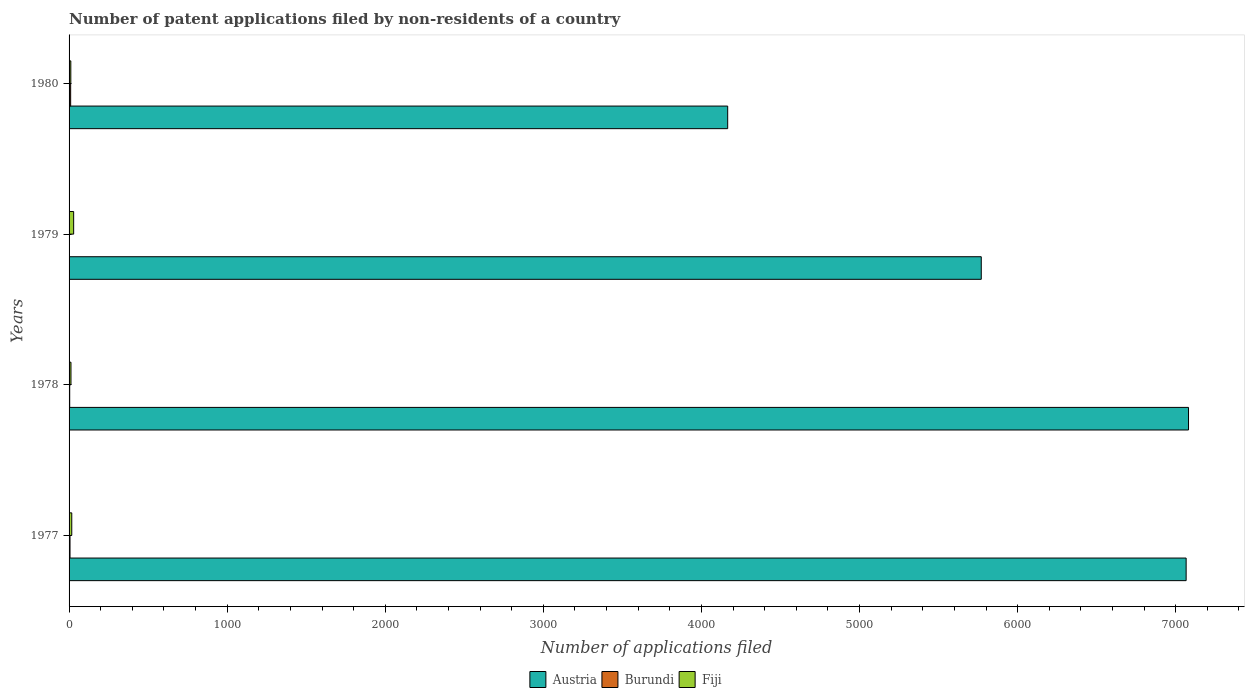Are the number of bars per tick equal to the number of legend labels?
Your answer should be compact. Yes. How many bars are there on the 2nd tick from the top?
Offer a very short reply. 3. How many bars are there on the 4th tick from the bottom?
Offer a very short reply. 3. What is the label of the 4th group of bars from the top?
Give a very brief answer. 1977. In how many cases, is the number of bars for a given year not equal to the number of legend labels?
Your answer should be very brief. 0. What is the number of applications filed in Fiji in 1977?
Make the answer very short. 17. In which year was the number of applications filed in Austria maximum?
Keep it short and to the point. 1978. In which year was the number of applications filed in Fiji minimum?
Your answer should be compact. 1980. What is the total number of applications filed in Austria in the graph?
Your answer should be very brief. 2.41e+04. What is the difference between the number of applications filed in Austria in 1979 and the number of applications filed in Fiji in 1978?
Offer a very short reply. 5758. What is the average number of applications filed in Burundi per year?
Offer a very short reply. 5.25. In the year 1977, what is the difference between the number of applications filed in Austria and number of applications filed in Fiji?
Your answer should be very brief. 7049. Is the number of applications filed in Burundi in 1978 less than that in 1979?
Offer a very short reply. No. What is the difference between the highest and the second highest number of applications filed in Fiji?
Your response must be concise. 12. What is the difference between the highest and the lowest number of applications filed in Austria?
Your answer should be compact. 2915. In how many years, is the number of applications filed in Fiji greater than the average number of applications filed in Fiji taken over all years?
Offer a very short reply. 1. What does the 1st bar from the top in 1977 represents?
Your answer should be very brief. Fiji. What does the 3rd bar from the bottom in 1979 represents?
Provide a succinct answer. Fiji. Is it the case that in every year, the sum of the number of applications filed in Fiji and number of applications filed in Burundi is greater than the number of applications filed in Austria?
Your answer should be very brief. No. How many bars are there?
Your response must be concise. 12. What is the difference between two consecutive major ticks on the X-axis?
Your answer should be compact. 1000. Does the graph contain any zero values?
Provide a short and direct response. No. How many legend labels are there?
Give a very brief answer. 3. How are the legend labels stacked?
Make the answer very short. Horizontal. What is the title of the graph?
Make the answer very short. Number of patent applications filed by non-residents of a country. What is the label or title of the X-axis?
Your answer should be very brief. Number of applications filed. What is the Number of applications filed of Austria in 1977?
Give a very brief answer. 7066. What is the Number of applications filed in Burundi in 1977?
Keep it short and to the point. 6. What is the Number of applications filed of Fiji in 1977?
Offer a very short reply. 17. What is the Number of applications filed of Austria in 1978?
Ensure brevity in your answer.  7081. What is the Number of applications filed of Burundi in 1978?
Provide a short and direct response. 4. What is the Number of applications filed in Austria in 1979?
Ensure brevity in your answer.  5770. What is the Number of applications filed of Austria in 1980?
Offer a terse response. 4166. What is the Number of applications filed in Burundi in 1980?
Your response must be concise. 10. Across all years, what is the maximum Number of applications filed of Austria?
Offer a terse response. 7081. Across all years, what is the maximum Number of applications filed in Burundi?
Your response must be concise. 10. Across all years, what is the maximum Number of applications filed of Fiji?
Offer a terse response. 29. Across all years, what is the minimum Number of applications filed in Austria?
Provide a succinct answer. 4166. Across all years, what is the minimum Number of applications filed in Fiji?
Provide a succinct answer. 11. What is the total Number of applications filed of Austria in the graph?
Your answer should be compact. 2.41e+04. What is the total Number of applications filed of Burundi in the graph?
Your answer should be compact. 21. What is the difference between the Number of applications filed of Austria in 1977 and that in 1978?
Make the answer very short. -15. What is the difference between the Number of applications filed of Burundi in 1977 and that in 1978?
Your answer should be very brief. 2. What is the difference between the Number of applications filed of Austria in 1977 and that in 1979?
Your answer should be very brief. 1296. What is the difference between the Number of applications filed in Burundi in 1977 and that in 1979?
Offer a terse response. 5. What is the difference between the Number of applications filed in Austria in 1977 and that in 1980?
Provide a succinct answer. 2900. What is the difference between the Number of applications filed of Burundi in 1977 and that in 1980?
Ensure brevity in your answer.  -4. What is the difference between the Number of applications filed in Austria in 1978 and that in 1979?
Your response must be concise. 1311. What is the difference between the Number of applications filed of Burundi in 1978 and that in 1979?
Your answer should be very brief. 3. What is the difference between the Number of applications filed in Fiji in 1978 and that in 1979?
Ensure brevity in your answer.  -17. What is the difference between the Number of applications filed of Austria in 1978 and that in 1980?
Keep it short and to the point. 2915. What is the difference between the Number of applications filed of Burundi in 1978 and that in 1980?
Your answer should be compact. -6. What is the difference between the Number of applications filed in Fiji in 1978 and that in 1980?
Offer a very short reply. 1. What is the difference between the Number of applications filed of Austria in 1979 and that in 1980?
Your response must be concise. 1604. What is the difference between the Number of applications filed of Burundi in 1979 and that in 1980?
Your response must be concise. -9. What is the difference between the Number of applications filed in Fiji in 1979 and that in 1980?
Provide a succinct answer. 18. What is the difference between the Number of applications filed in Austria in 1977 and the Number of applications filed in Burundi in 1978?
Give a very brief answer. 7062. What is the difference between the Number of applications filed in Austria in 1977 and the Number of applications filed in Fiji in 1978?
Make the answer very short. 7054. What is the difference between the Number of applications filed in Burundi in 1977 and the Number of applications filed in Fiji in 1978?
Provide a short and direct response. -6. What is the difference between the Number of applications filed of Austria in 1977 and the Number of applications filed of Burundi in 1979?
Your answer should be compact. 7065. What is the difference between the Number of applications filed of Austria in 1977 and the Number of applications filed of Fiji in 1979?
Provide a succinct answer. 7037. What is the difference between the Number of applications filed in Burundi in 1977 and the Number of applications filed in Fiji in 1979?
Offer a very short reply. -23. What is the difference between the Number of applications filed in Austria in 1977 and the Number of applications filed in Burundi in 1980?
Offer a very short reply. 7056. What is the difference between the Number of applications filed of Austria in 1977 and the Number of applications filed of Fiji in 1980?
Offer a very short reply. 7055. What is the difference between the Number of applications filed in Burundi in 1977 and the Number of applications filed in Fiji in 1980?
Ensure brevity in your answer.  -5. What is the difference between the Number of applications filed of Austria in 1978 and the Number of applications filed of Burundi in 1979?
Provide a succinct answer. 7080. What is the difference between the Number of applications filed in Austria in 1978 and the Number of applications filed in Fiji in 1979?
Offer a very short reply. 7052. What is the difference between the Number of applications filed of Austria in 1978 and the Number of applications filed of Burundi in 1980?
Provide a succinct answer. 7071. What is the difference between the Number of applications filed of Austria in 1978 and the Number of applications filed of Fiji in 1980?
Offer a very short reply. 7070. What is the difference between the Number of applications filed of Burundi in 1978 and the Number of applications filed of Fiji in 1980?
Provide a short and direct response. -7. What is the difference between the Number of applications filed of Austria in 1979 and the Number of applications filed of Burundi in 1980?
Offer a terse response. 5760. What is the difference between the Number of applications filed in Austria in 1979 and the Number of applications filed in Fiji in 1980?
Your answer should be compact. 5759. What is the average Number of applications filed in Austria per year?
Your answer should be very brief. 6020.75. What is the average Number of applications filed in Burundi per year?
Your answer should be very brief. 5.25. What is the average Number of applications filed in Fiji per year?
Make the answer very short. 17.25. In the year 1977, what is the difference between the Number of applications filed of Austria and Number of applications filed of Burundi?
Your answer should be very brief. 7060. In the year 1977, what is the difference between the Number of applications filed of Austria and Number of applications filed of Fiji?
Your answer should be very brief. 7049. In the year 1978, what is the difference between the Number of applications filed of Austria and Number of applications filed of Burundi?
Keep it short and to the point. 7077. In the year 1978, what is the difference between the Number of applications filed in Austria and Number of applications filed in Fiji?
Keep it short and to the point. 7069. In the year 1978, what is the difference between the Number of applications filed in Burundi and Number of applications filed in Fiji?
Give a very brief answer. -8. In the year 1979, what is the difference between the Number of applications filed in Austria and Number of applications filed in Burundi?
Your answer should be compact. 5769. In the year 1979, what is the difference between the Number of applications filed in Austria and Number of applications filed in Fiji?
Provide a succinct answer. 5741. In the year 1980, what is the difference between the Number of applications filed of Austria and Number of applications filed of Burundi?
Keep it short and to the point. 4156. In the year 1980, what is the difference between the Number of applications filed in Austria and Number of applications filed in Fiji?
Your response must be concise. 4155. What is the ratio of the Number of applications filed of Austria in 1977 to that in 1978?
Offer a terse response. 1. What is the ratio of the Number of applications filed of Burundi in 1977 to that in 1978?
Your response must be concise. 1.5. What is the ratio of the Number of applications filed of Fiji in 1977 to that in 1978?
Give a very brief answer. 1.42. What is the ratio of the Number of applications filed in Austria in 1977 to that in 1979?
Your response must be concise. 1.22. What is the ratio of the Number of applications filed of Fiji in 1977 to that in 1979?
Offer a very short reply. 0.59. What is the ratio of the Number of applications filed of Austria in 1977 to that in 1980?
Ensure brevity in your answer.  1.7. What is the ratio of the Number of applications filed of Fiji in 1977 to that in 1980?
Provide a succinct answer. 1.55. What is the ratio of the Number of applications filed in Austria in 1978 to that in 1979?
Offer a terse response. 1.23. What is the ratio of the Number of applications filed in Fiji in 1978 to that in 1979?
Provide a succinct answer. 0.41. What is the ratio of the Number of applications filed of Austria in 1978 to that in 1980?
Provide a succinct answer. 1.7. What is the ratio of the Number of applications filed of Burundi in 1978 to that in 1980?
Give a very brief answer. 0.4. What is the ratio of the Number of applications filed in Fiji in 1978 to that in 1980?
Your answer should be compact. 1.09. What is the ratio of the Number of applications filed in Austria in 1979 to that in 1980?
Offer a terse response. 1.39. What is the ratio of the Number of applications filed in Burundi in 1979 to that in 1980?
Provide a short and direct response. 0.1. What is the ratio of the Number of applications filed of Fiji in 1979 to that in 1980?
Offer a very short reply. 2.64. What is the difference between the highest and the lowest Number of applications filed in Austria?
Your answer should be compact. 2915. What is the difference between the highest and the lowest Number of applications filed in Burundi?
Your response must be concise. 9. What is the difference between the highest and the lowest Number of applications filed in Fiji?
Provide a succinct answer. 18. 